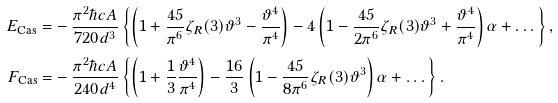<formula> <loc_0><loc_0><loc_500><loc_500>E _ { \text {Cas} } = & - \frac { \pi ^ { 2 } \hbar { c } A } { 7 2 0 d ^ { 3 } } \left \{ \left ( 1 + \frac { 4 5 } { \pi ^ { 6 } } \zeta _ { R } ( 3 ) \vartheta ^ { 3 } - \frac { \vartheta ^ { 4 } } { \pi ^ { 4 } } \right ) - 4 \left ( 1 - \frac { 4 5 } { 2 \pi ^ { 6 } } \zeta _ { R } ( 3 ) \vartheta ^ { 3 } + \frac { \vartheta ^ { 4 } } { \pi ^ { 4 } } \right ) \alpha + \dots \right \} , \\ F _ { \text {Cas} } = & - \frac { \pi ^ { 2 } \hbar { c } A } { 2 4 0 d ^ { 4 } } \left \{ \left ( 1 + \frac { 1 } { 3 } \frac { \vartheta ^ { 4 } } { \pi ^ { 4 } } \right ) - \frac { 1 6 } { 3 } \left ( 1 - \frac { 4 5 } { 8 \pi ^ { 6 } } \zeta _ { R } ( 3 ) \vartheta ^ { 3 } \right ) \alpha + \dots \right \} .</formula> 